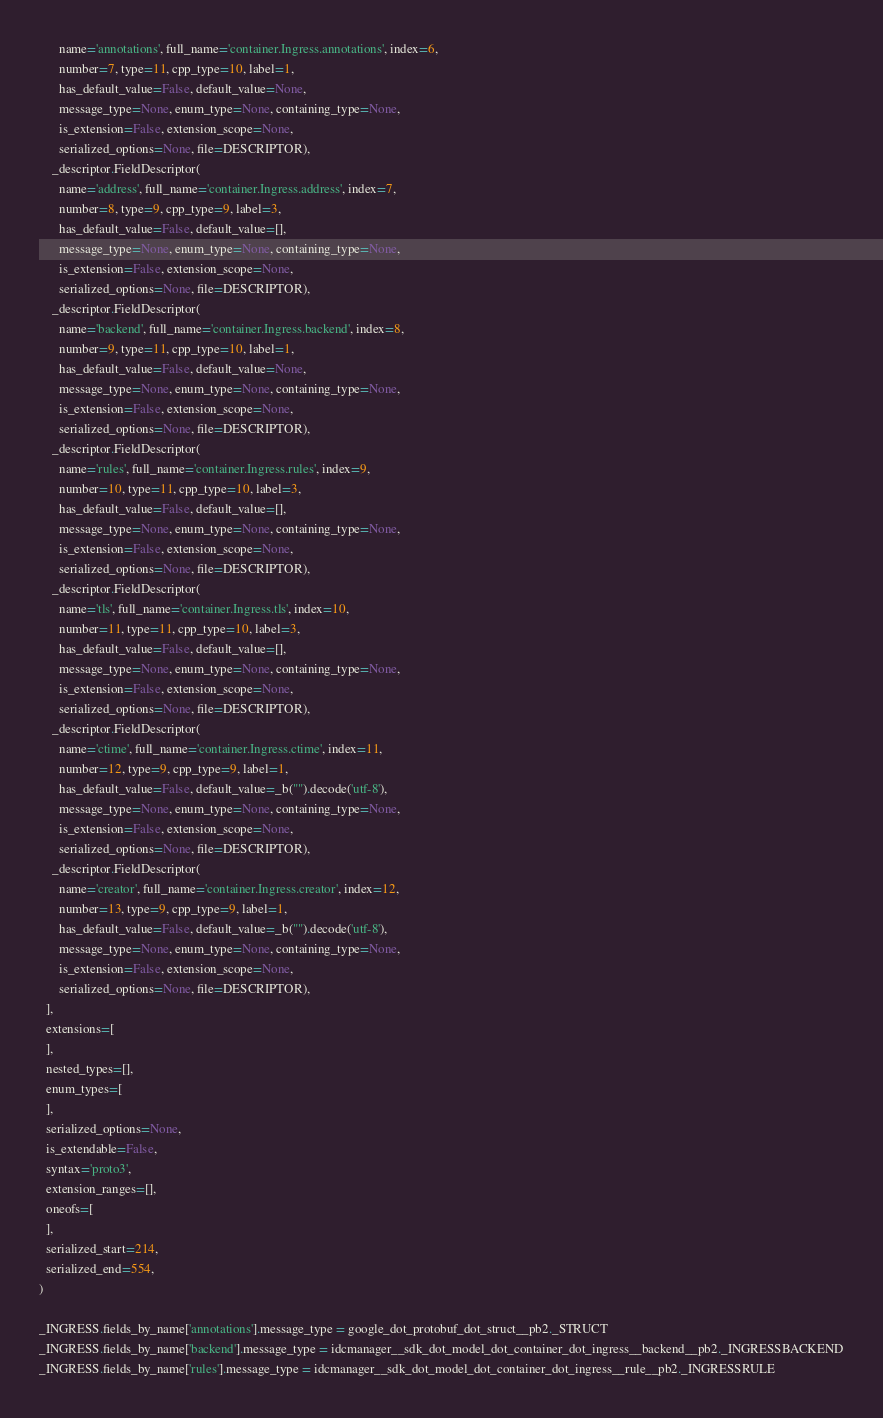<code> <loc_0><loc_0><loc_500><loc_500><_Python_>      name='annotations', full_name='container.Ingress.annotations', index=6,
      number=7, type=11, cpp_type=10, label=1,
      has_default_value=False, default_value=None,
      message_type=None, enum_type=None, containing_type=None,
      is_extension=False, extension_scope=None,
      serialized_options=None, file=DESCRIPTOR),
    _descriptor.FieldDescriptor(
      name='address', full_name='container.Ingress.address', index=7,
      number=8, type=9, cpp_type=9, label=3,
      has_default_value=False, default_value=[],
      message_type=None, enum_type=None, containing_type=None,
      is_extension=False, extension_scope=None,
      serialized_options=None, file=DESCRIPTOR),
    _descriptor.FieldDescriptor(
      name='backend', full_name='container.Ingress.backend', index=8,
      number=9, type=11, cpp_type=10, label=1,
      has_default_value=False, default_value=None,
      message_type=None, enum_type=None, containing_type=None,
      is_extension=False, extension_scope=None,
      serialized_options=None, file=DESCRIPTOR),
    _descriptor.FieldDescriptor(
      name='rules', full_name='container.Ingress.rules', index=9,
      number=10, type=11, cpp_type=10, label=3,
      has_default_value=False, default_value=[],
      message_type=None, enum_type=None, containing_type=None,
      is_extension=False, extension_scope=None,
      serialized_options=None, file=DESCRIPTOR),
    _descriptor.FieldDescriptor(
      name='tls', full_name='container.Ingress.tls', index=10,
      number=11, type=11, cpp_type=10, label=3,
      has_default_value=False, default_value=[],
      message_type=None, enum_type=None, containing_type=None,
      is_extension=False, extension_scope=None,
      serialized_options=None, file=DESCRIPTOR),
    _descriptor.FieldDescriptor(
      name='ctime', full_name='container.Ingress.ctime', index=11,
      number=12, type=9, cpp_type=9, label=1,
      has_default_value=False, default_value=_b("").decode('utf-8'),
      message_type=None, enum_type=None, containing_type=None,
      is_extension=False, extension_scope=None,
      serialized_options=None, file=DESCRIPTOR),
    _descriptor.FieldDescriptor(
      name='creator', full_name='container.Ingress.creator', index=12,
      number=13, type=9, cpp_type=9, label=1,
      has_default_value=False, default_value=_b("").decode('utf-8'),
      message_type=None, enum_type=None, containing_type=None,
      is_extension=False, extension_scope=None,
      serialized_options=None, file=DESCRIPTOR),
  ],
  extensions=[
  ],
  nested_types=[],
  enum_types=[
  ],
  serialized_options=None,
  is_extendable=False,
  syntax='proto3',
  extension_ranges=[],
  oneofs=[
  ],
  serialized_start=214,
  serialized_end=554,
)

_INGRESS.fields_by_name['annotations'].message_type = google_dot_protobuf_dot_struct__pb2._STRUCT
_INGRESS.fields_by_name['backend'].message_type = idcmanager__sdk_dot_model_dot_container_dot_ingress__backend__pb2._INGRESSBACKEND
_INGRESS.fields_by_name['rules'].message_type = idcmanager__sdk_dot_model_dot_container_dot_ingress__rule__pb2._INGRESSRULE</code> 